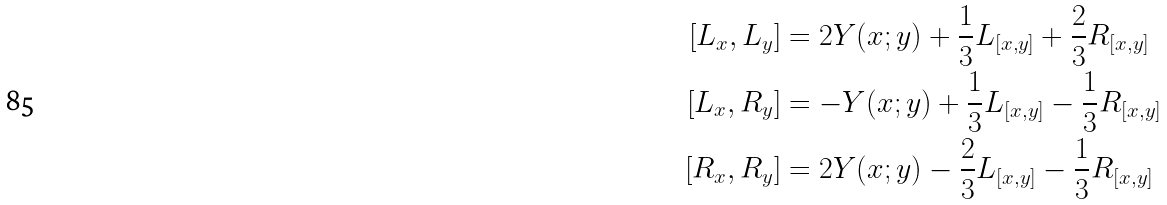<formula> <loc_0><loc_0><loc_500><loc_500>[ L _ { x } , L _ { y } ] & = 2 Y ( x ; y ) + \frac { 1 } { 3 } L _ { [ x , y ] } + \frac { 2 } { 3 } R _ { [ x , y ] } \\ [ L _ { x } , R _ { y } ] & = - Y ( x ; y ) + \frac { 1 } { 3 } L _ { [ x , y ] } - \frac { 1 } { 3 } R _ { [ x , y ] } \\ [ R _ { x } , R _ { y } ] & = 2 Y ( x ; y ) - \frac { 2 } { 3 } L _ { [ x , y ] } - \frac { 1 } { 3 } R _ { [ x , y ] }</formula> 